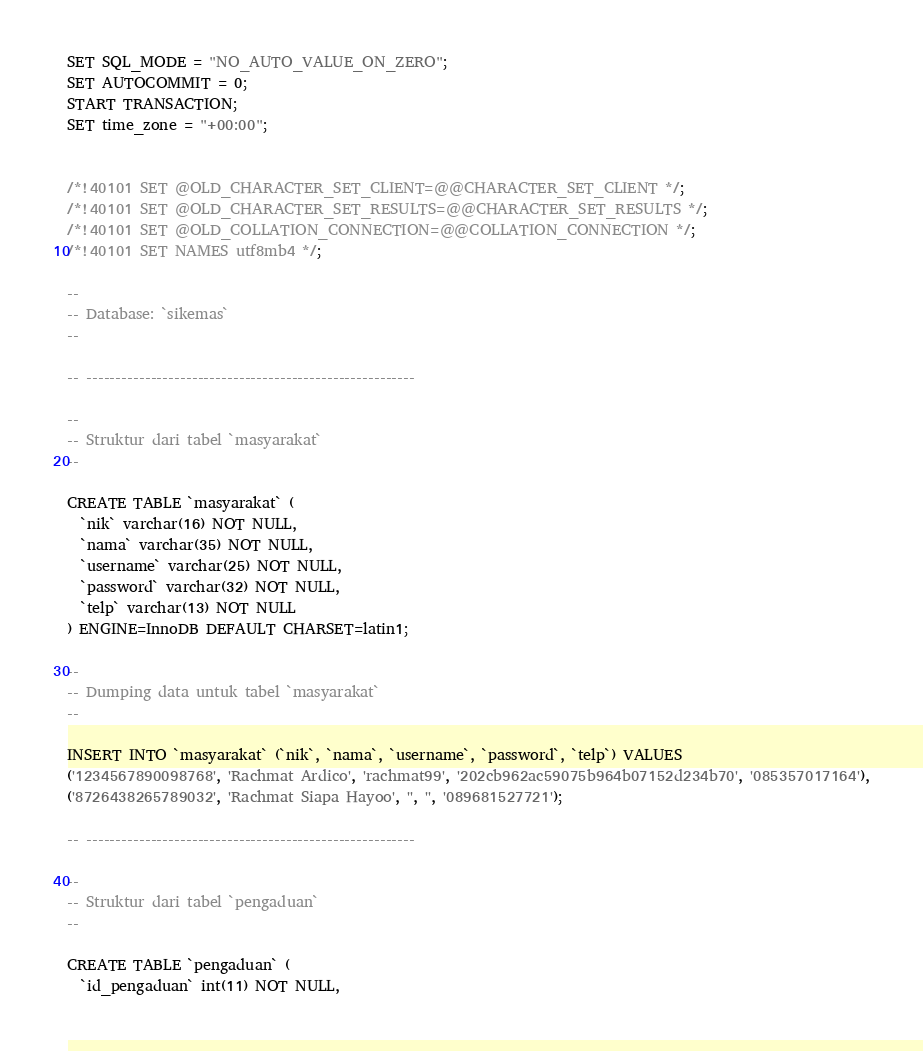Convert code to text. <code><loc_0><loc_0><loc_500><loc_500><_SQL_>SET SQL_MODE = "NO_AUTO_VALUE_ON_ZERO";
SET AUTOCOMMIT = 0;
START TRANSACTION;
SET time_zone = "+00:00";


/*!40101 SET @OLD_CHARACTER_SET_CLIENT=@@CHARACTER_SET_CLIENT */;
/*!40101 SET @OLD_CHARACTER_SET_RESULTS=@@CHARACTER_SET_RESULTS */;
/*!40101 SET @OLD_COLLATION_CONNECTION=@@COLLATION_CONNECTION */;
/*!40101 SET NAMES utf8mb4 */;

--
-- Database: `sikemas`
--

-- --------------------------------------------------------

--
-- Struktur dari tabel `masyarakat`
--

CREATE TABLE `masyarakat` (
  `nik` varchar(16) NOT NULL,
  `nama` varchar(35) NOT NULL,
  `username` varchar(25) NOT NULL,
  `password` varchar(32) NOT NULL,
  `telp` varchar(13) NOT NULL
) ENGINE=InnoDB DEFAULT CHARSET=latin1;

--
-- Dumping data untuk tabel `masyarakat`
--

INSERT INTO `masyarakat` (`nik`, `nama`, `username`, `password`, `telp`) VALUES
('1234567890098768', 'Rachmat Ardico', 'rachmat99', '202cb962ac59075b964b07152d234b70', '085357017164'),
('8726438265789032', 'Rachmat Siapa Hayoo', '', '', '089681527721');

-- --------------------------------------------------------

--
-- Struktur dari tabel `pengaduan`
--

CREATE TABLE `pengaduan` (
  `id_pengaduan` int(11) NOT NULL,</code> 